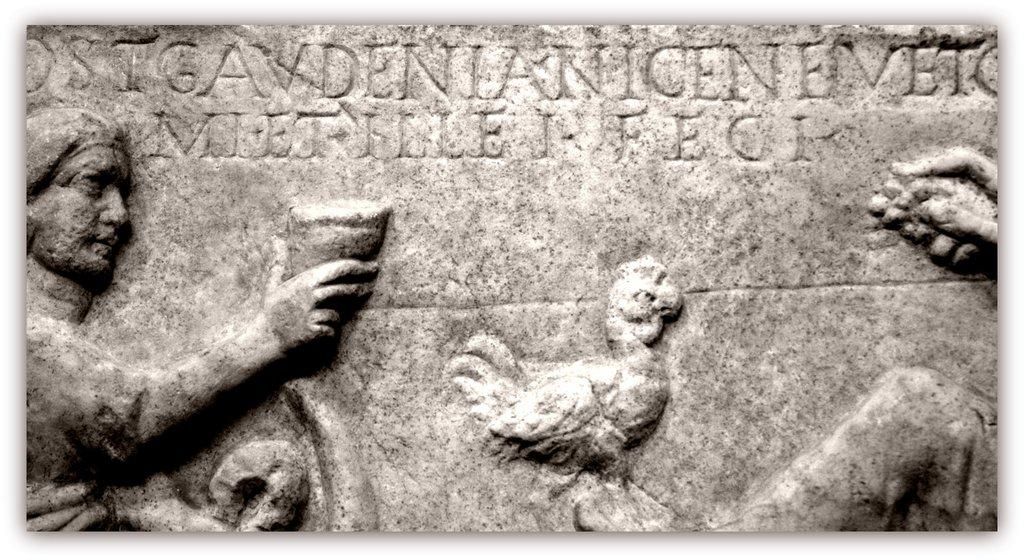What is the main subject of the image? The main subject of the image is a memorial stone. What is depicted on the memorial stone? There is a sculpture chiseled on the memorial stone. Are there any living creatures present in the image? Yes, there is a bird in the image. What book is the person reading in the image? There is no person or book present in the image. 